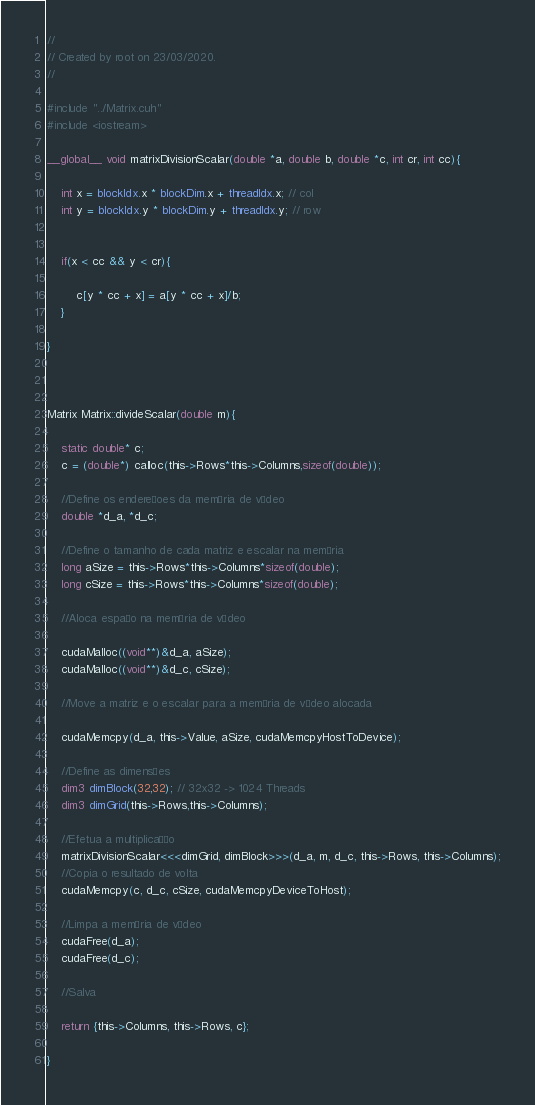<code> <loc_0><loc_0><loc_500><loc_500><_Cuda_>//
// Created by root on 23/03/2020.
//

#include "../Matrix.cuh"
#include <iostream>

__global__ void matrixDivisionScalar(double *a, double b, double *c, int cr, int cc){

    int x = blockIdx.x * blockDim.x + threadIdx.x; // col
    int y = blockIdx.y * blockDim.y + threadIdx.y; // row


    if(x < cc && y < cr){

        c[y * cc + x] = a[y * cc + x]/b;
    }

}



Matrix Matrix::divideScalar(double m){

    static double* c;
    c = (double*) calloc(this->Rows*this->Columns,sizeof(double));

    //Define os endereçoes da memória de vídeo
    double *d_a, *d_c;

    //Define o tamanho de cada matriz e escalar na memória
    long aSize = this->Rows*this->Columns*sizeof(double);
    long cSize = this->Rows*this->Columns*sizeof(double);

    //Aloca espaço na memória de vídeo

    cudaMalloc((void**)&d_a, aSize);
    cudaMalloc((void**)&d_c, cSize);

    //Move a matriz e o escalar para a memória de vídeo alocada

    cudaMemcpy(d_a, this->Value, aSize, cudaMemcpyHostToDevice);

    //Define as dimensões
    dim3 dimBlock(32,32); // 32x32 -> 1024 Threads
    dim3 dimGrid(this->Rows,this->Columns);

    //Efetua a multiplicação
    matrixDivisionScalar<<<dimGrid, dimBlock>>>(d_a, m, d_c, this->Rows, this->Columns);
    //Copia o resultado de volta
    cudaMemcpy(c, d_c, cSize, cudaMemcpyDeviceToHost);

    //Limpa a memória de vídeo
    cudaFree(d_a);
    cudaFree(d_c);

    //Salva

    return {this->Columns, this->Rows, c};

}


</code> 